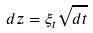Convert formula to latex. <formula><loc_0><loc_0><loc_500><loc_500>d z = \xi _ { t } \sqrt { d t }</formula> 